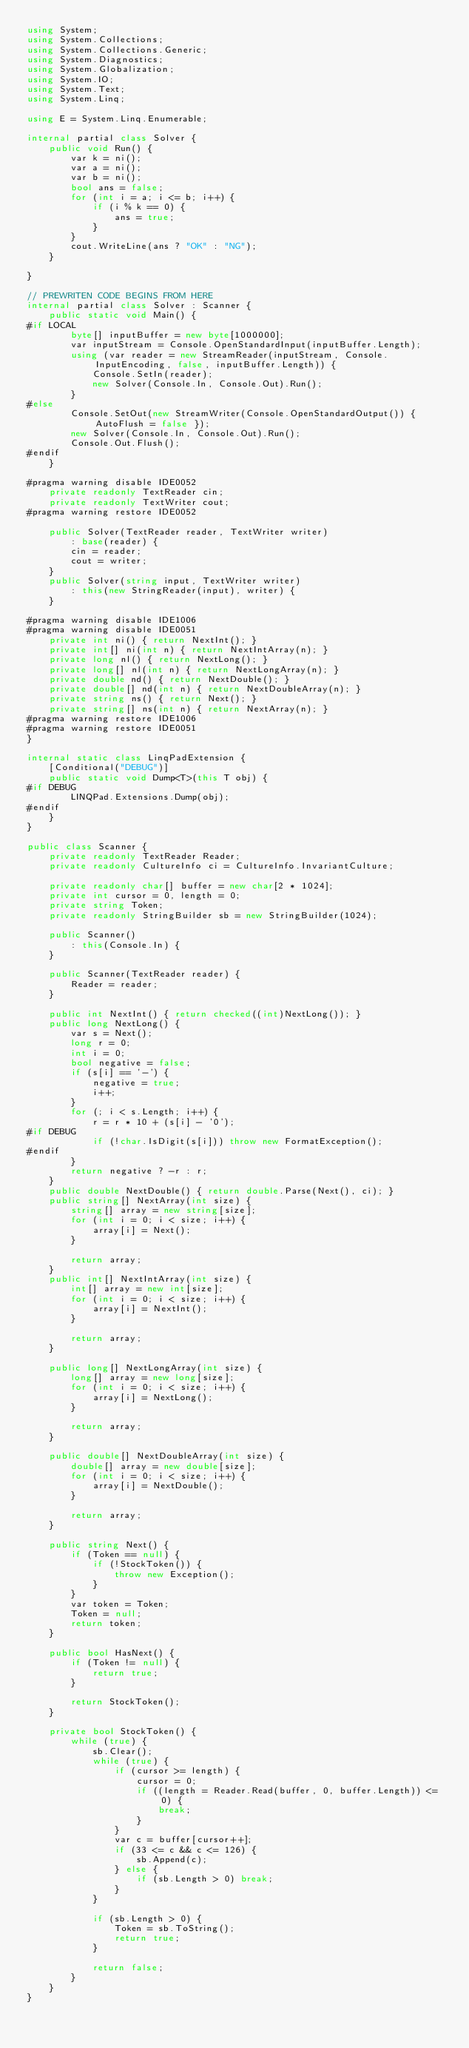<code> <loc_0><loc_0><loc_500><loc_500><_C#_>using System;
using System.Collections;
using System.Collections.Generic;
using System.Diagnostics;
using System.Globalization;
using System.IO;
using System.Text;
using System.Linq;

using E = System.Linq.Enumerable;

internal partial class Solver {
    public void Run() {
        var k = ni();
        var a = ni();
        var b = ni();
        bool ans = false;
        for (int i = a; i <= b; i++) {
            if (i % k == 0) {
                ans = true;
            }
        }
        cout.WriteLine(ans ? "OK" : "NG");
    }

}

// PREWRITEN CODE BEGINS FROM HERE
internal partial class Solver : Scanner {
    public static void Main() {
#if LOCAL
        byte[] inputBuffer = new byte[1000000];
        var inputStream = Console.OpenStandardInput(inputBuffer.Length);
        using (var reader = new StreamReader(inputStream, Console.InputEncoding, false, inputBuffer.Length)) {
            Console.SetIn(reader);
            new Solver(Console.In, Console.Out).Run();
        }
#else
        Console.SetOut(new StreamWriter(Console.OpenStandardOutput()) { AutoFlush = false });
        new Solver(Console.In, Console.Out).Run();
        Console.Out.Flush();
#endif
    }

#pragma warning disable IDE0052
    private readonly TextReader cin;
    private readonly TextWriter cout;
#pragma warning restore IDE0052

    public Solver(TextReader reader, TextWriter writer)
        : base(reader) {
        cin = reader;
        cout = writer;
    }
    public Solver(string input, TextWriter writer)
        : this(new StringReader(input), writer) {
    }

#pragma warning disable IDE1006
#pragma warning disable IDE0051
    private int ni() { return NextInt(); }
    private int[] ni(int n) { return NextIntArray(n); }
    private long nl() { return NextLong(); }
    private long[] nl(int n) { return NextLongArray(n); }
    private double nd() { return NextDouble(); }
    private double[] nd(int n) { return NextDoubleArray(n); }
    private string ns() { return Next(); }
    private string[] ns(int n) { return NextArray(n); }
#pragma warning restore IDE1006
#pragma warning restore IDE0051
}

internal static class LinqPadExtension {
    [Conditional("DEBUG")]
    public static void Dump<T>(this T obj) {
#if DEBUG
        LINQPad.Extensions.Dump(obj);
#endif
    }
}

public class Scanner {
    private readonly TextReader Reader;
    private readonly CultureInfo ci = CultureInfo.InvariantCulture;

    private readonly char[] buffer = new char[2 * 1024];
    private int cursor = 0, length = 0;
    private string Token;
    private readonly StringBuilder sb = new StringBuilder(1024);

    public Scanner()
        : this(Console.In) {
    }

    public Scanner(TextReader reader) {
        Reader = reader;
    }

    public int NextInt() { return checked((int)NextLong()); }
    public long NextLong() {
        var s = Next();
        long r = 0;
        int i = 0;
        bool negative = false;
        if (s[i] == '-') {
            negative = true;
            i++;
        }
        for (; i < s.Length; i++) {
            r = r * 10 + (s[i] - '0');
#if DEBUG
            if (!char.IsDigit(s[i])) throw new FormatException();
#endif
        }
        return negative ? -r : r;
    }
    public double NextDouble() { return double.Parse(Next(), ci); }
    public string[] NextArray(int size) {
        string[] array = new string[size];
        for (int i = 0; i < size; i++) {
            array[i] = Next();
        }

        return array;
    }
    public int[] NextIntArray(int size) {
        int[] array = new int[size];
        for (int i = 0; i < size; i++) {
            array[i] = NextInt();
        }

        return array;
    }

    public long[] NextLongArray(int size) {
        long[] array = new long[size];
        for (int i = 0; i < size; i++) {
            array[i] = NextLong();
        }

        return array;
    }

    public double[] NextDoubleArray(int size) {
        double[] array = new double[size];
        for (int i = 0; i < size; i++) {
            array[i] = NextDouble();
        }

        return array;
    }

    public string Next() {
        if (Token == null) {
            if (!StockToken()) {
                throw new Exception();
            }
        }
        var token = Token;
        Token = null;
        return token;
    }

    public bool HasNext() {
        if (Token != null) {
            return true;
        }

        return StockToken();
    }

    private bool StockToken() {
        while (true) {
            sb.Clear();
            while (true) {
                if (cursor >= length) {
                    cursor = 0;
                    if ((length = Reader.Read(buffer, 0, buffer.Length)) <= 0) {
                        break;
                    }
                }
                var c = buffer[cursor++];
                if (33 <= c && c <= 126) {
                    sb.Append(c);
                } else {
                    if (sb.Length > 0) break;
                }
            }

            if (sb.Length > 0) {
                Token = sb.ToString();
                return true;
            }

            return false;
        }
    }
}</code> 